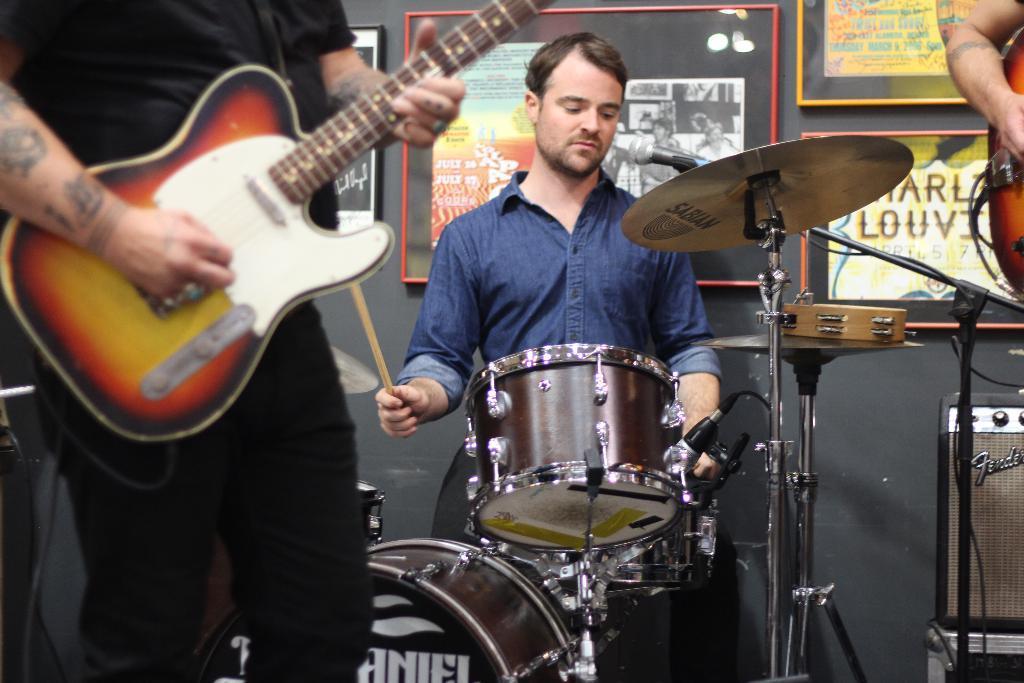Describe this image in one or two sentences. In this image we can see three persons are playing musical instruments, one of them is playing jazz, and other two are playing guitar, we can see some photo frames on the wall with persons images and some texts written on it, also we can see an electronic instrument. 